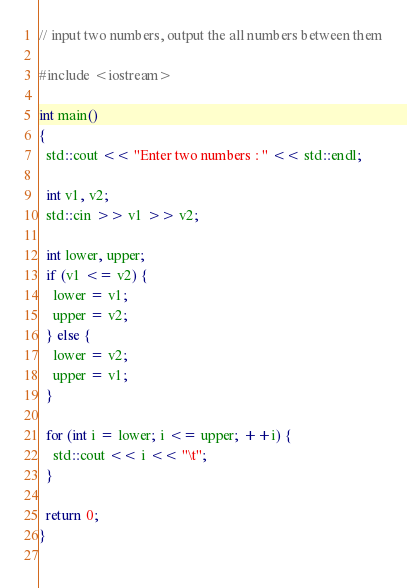Convert code to text. <code><loc_0><loc_0><loc_500><loc_500><_C++_>// input two numbers, output the all numbers between them

#include <iostream>

int main()
{
  std::cout << "Enter two numbers : " << std::endl;

  int v1, v2;
  std::cin >> v1 >> v2;

  int lower, upper;
  if (v1 <= v2) {
    lower = v1;
    upper = v2;
  } else {
    lower = v2;
    upper = v1;
  }

  for (int i = lower; i <= upper; ++i) {
    std::cout << i << "\t";
  }

  return 0;
}
  
</code> 